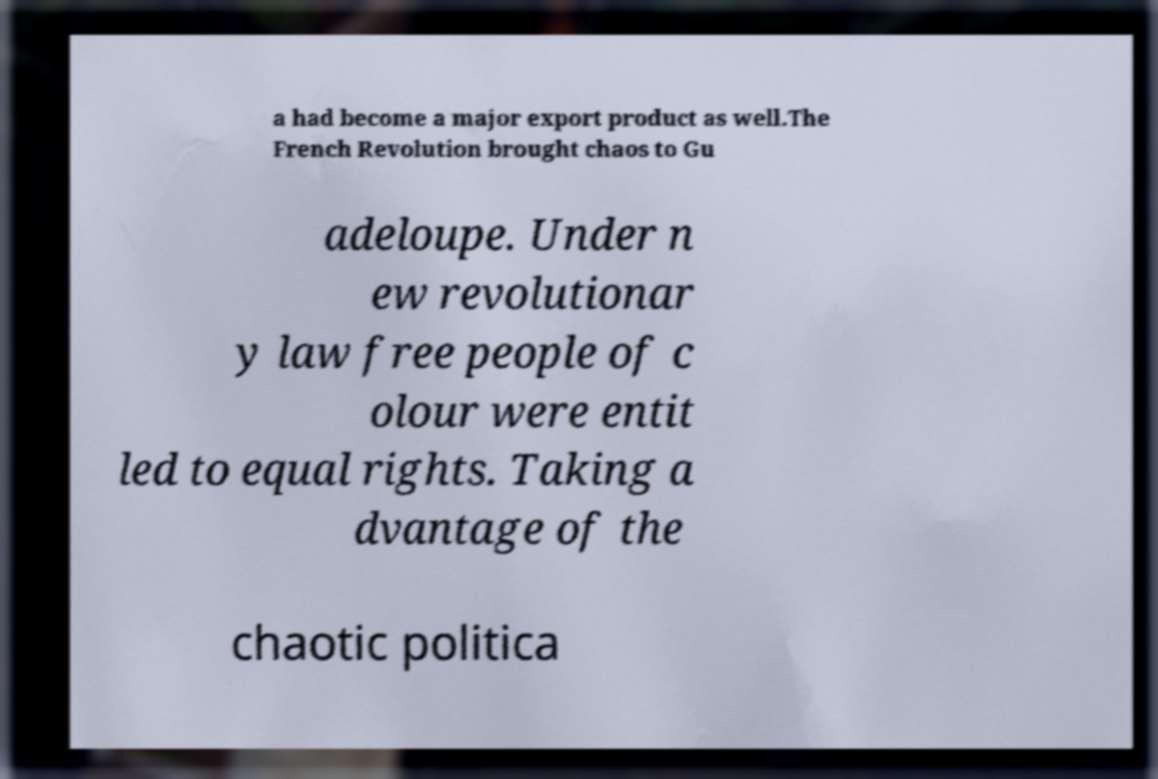Please read and relay the text visible in this image. What does it say? a had become a major export product as well.The French Revolution brought chaos to Gu adeloupe. Under n ew revolutionar y law free people of c olour were entit led to equal rights. Taking a dvantage of the chaotic politica 